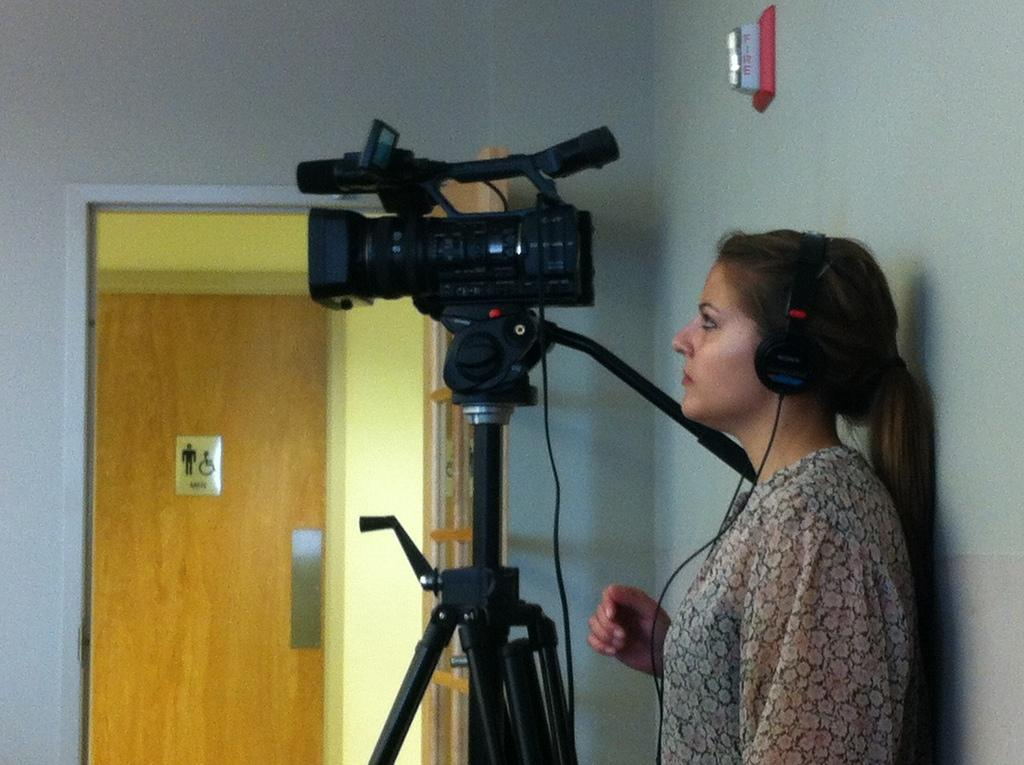Who is present in the image? There is a person in the image. What is the person wearing? The person is wearing headsets. What equipment can be seen in the image? There is a camera on a stand in the image. What architectural features are visible in the image? There is a door and a wall visible in the image. What type of list is being held by the person in the image? There is no list present in the image; the person is wearing headsets and there is a camera on a stand. 